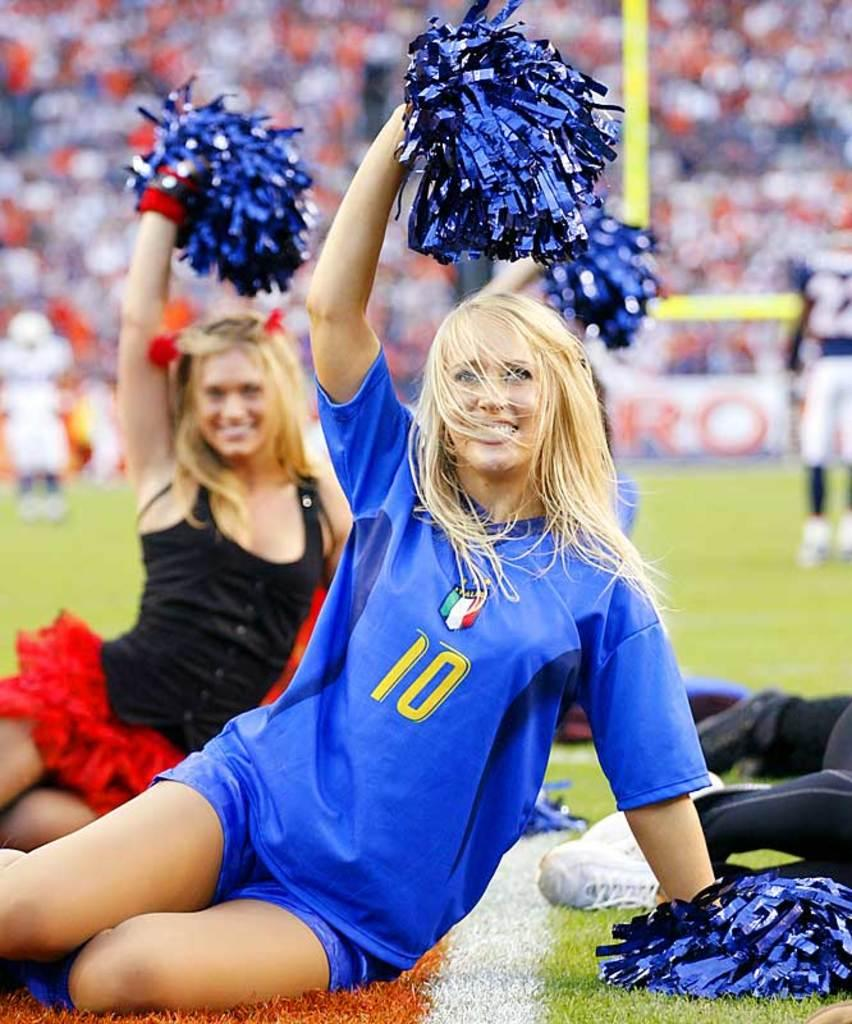<image>
Render a clear and concise summary of the photo. Woman wearing a blue shirt that has the number 10 on it. 